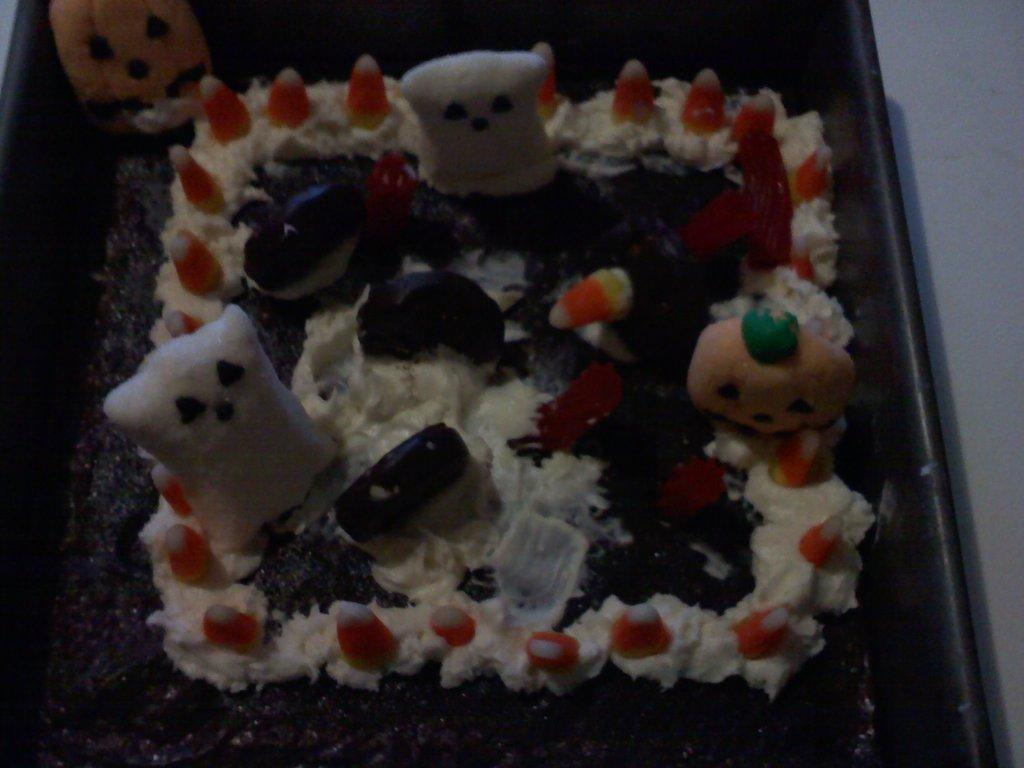What is the main object in the image? There is a cake in the image. What else can be seen in the image besides the cake? There are toys in the image. Where are the cake and toys located? The cake and toys are in a container. What can be seen in the background of the image? There is a wall visible in the image. What type of protest is happening in the image? There is no protest present in the image; it features a cake and toys in a container with a wall visible in the background. 